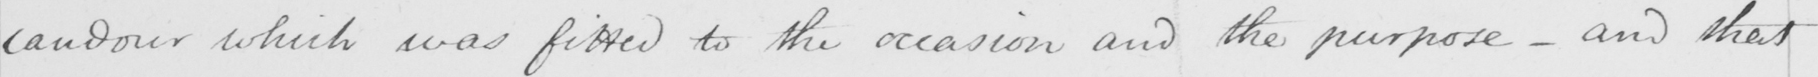Please transcribe the handwritten text in this image. candour which was fitted to the occasion and the purpose  _  and that 